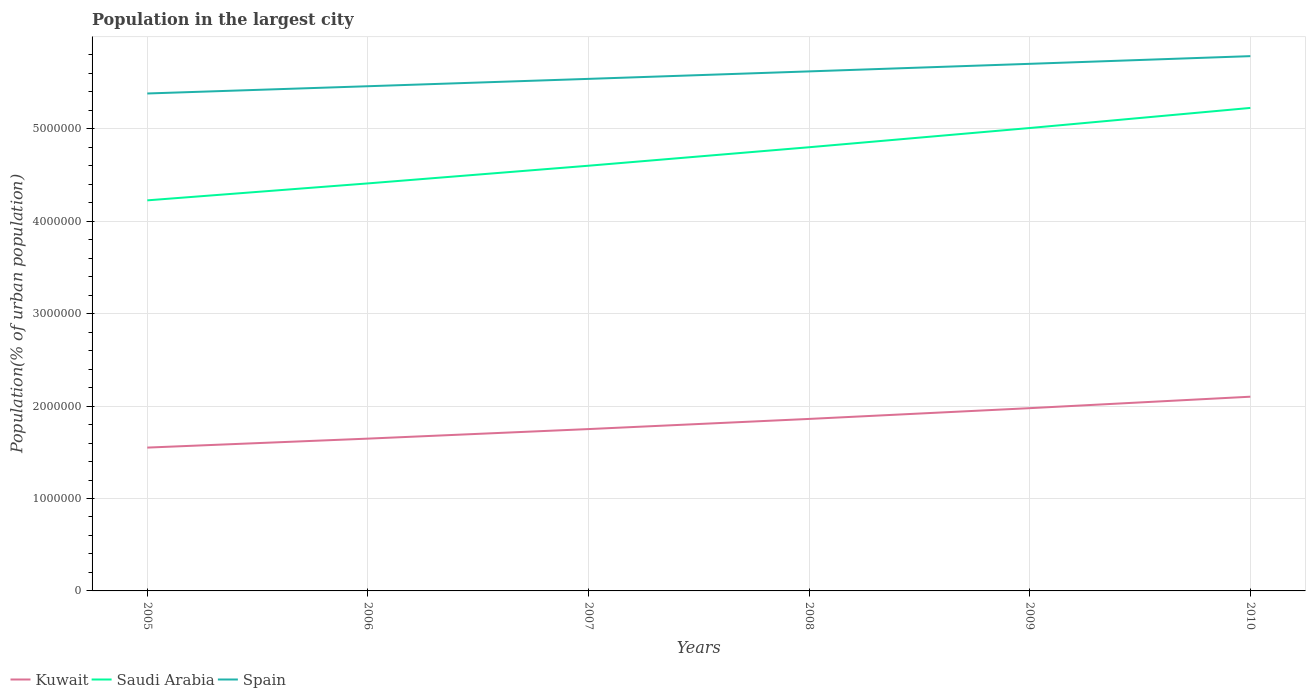Does the line corresponding to Kuwait intersect with the line corresponding to Saudi Arabia?
Provide a succinct answer. No. Is the number of lines equal to the number of legend labels?
Offer a very short reply. Yes. Across all years, what is the maximum population in the largest city in Spain?
Your answer should be very brief. 5.38e+06. In which year was the population in the largest city in Saudi Arabia maximum?
Provide a short and direct response. 2005. What is the total population in the largest city in Kuwait in the graph?
Provide a short and direct response. -2.26e+05. What is the difference between the highest and the second highest population in the largest city in Spain?
Provide a short and direct response. 4.04e+05. Is the population in the largest city in Saudi Arabia strictly greater than the population in the largest city in Kuwait over the years?
Keep it short and to the point. No. How many lines are there?
Your answer should be compact. 3. How many years are there in the graph?
Offer a terse response. 6. Does the graph contain grids?
Give a very brief answer. Yes. Where does the legend appear in the graph?
Provide a short and direct response. Bottom left. How are the legend labels stacked?
Offer a terse response. Horizontal. What is the title of the graph?
Provide a succinct answer. Population in the largest city. What is the label or title of the X-axis?
Your response must be concise. Years. What is the label or title of the Y-axis?
Make the answer very short. Population(% of urban population). What is the Population(% of urban population) of Kuwait in 2005?
Your response must be concise. 1.55e+06. What is the Population(% of urban population) of Saudi Arabia in 2005?
Ensure brevity in your answer.  4.23e+06. What is the Population(% of urban population) of Spain in 2005?
Give a very brief answer. 5.38e+06. What is the Population(% of urban population) of Kuwait in 2006?
Provide a short and direct response. 1.65e+06. What is the Population(% of urban population) of Saudi Arabia in 2006?
Offer a terse response. 4.41e+06. What is the Population(% of urban population) of Spain in 2006?
Offer a terse response. 5.46e+06. What is the Population(% of urban population) of Kuwait in 2007?
Provide a short and direct response. 1.75e+06. What is the Population(% of urban population) of Saudi Arabia in 2007?
Offer a terse response. 4.60e+06. What is the Population(% of urban population) of Spain in 2007?
Keep it short and to the point. 5.54e+06. What is the Population(% of urban population) in Kuwait in 2008?
Your response must be concise. 1.86e+06. What is the Population(% of urban population) in Saudi Arabia in 2008?
Make the answer very short. 4.80e+06. What is the Population(% of urban population) in Spain in 2008?
Your answer should be very brief. 5.62e+06. What is the Population(% of urban population) of Kuwait in 2009?
Offer a terse response. 1.98e+06. What is the Population(% of urban population) in Saudi Arabia in 2009?
Provide a short and direct response. 5.01e+06. What is the Population(% of urban population) in Spain in 2009?
Make the answer very short. 5.70e+06. What is the Population(% of urban population) of Kuwait in 2010?
Provide a succinct answer. 2.10e+06. What is the Population(% of urban population) of Saudi Arabia in 2010?
Offer a terse response. 5.23e+06. What is the Population(% of urban population) of Spain in 2010?
Provide a succinct answer. 5.79e+06. Across all years, what is the maximum Population(% of urban population) in Kuwait?
Ensure brevity in your answer.  2.10e+06. Across all years, what is the maximum Population(% of urban population) in Saudi Arabia?
Your answer should be compact. 5.23e+06. Across all years, what is the maximum Population(% of urban population) of Spain?
Your response must be concise. 5.79e+06. Across all years, what is the minimum Population(% of urban population) of Kuwait?
Provide a succinct answer. 1.55e+06. Across all years, what is the minimum Population(% of urban population) of Saudi Arabia?
Provide a succinct answer. 4.23e+06. Across all years, what is the minimum Population(% of urban population) in Spain?
Keep it short and to the point. 5.38e+06. What is the total Population(% of urban population) in Kuwait in the graph?
Give a very brief answer. 1.09e+07. What is the total Population(% of urban population) in Saudi Arabia in the graph?
Provide a succinct answer. 2.83e+07. What is the total Population(% of urban population) in Spain in the graph?
Provide a succinct answer. 3.35e+07. What is the difference between the Population(% of urban population) of Kuwait in 2005 and that in 2006?
Your response must be concise. -9.72e+04. What is the difference between the Population(% of urban population) in Saudi Arabia in 2005 and that in 2006?
Offer a very short reply. -1.83e+05. What is the difference between the Population(% of urban population) of Spain in 2005 and that in 2006?
Ensure brevity in your answer.  -7.85e+04. What is the difference between the Population(% of urban population) in Kuwait in 2005 and that in 2007?
Your answer should be very brief. -2.00e+05. What is the difference between the Population(% of urban population) in Saudi Arabia in 2005 and that in 2007?
Your answer should be very brief. -3.75e+05. What is the difference between the Population(% of urban population) of Spain in 2005 and that in 2007?
Provide a succinct answer. -1.58e+05. What is the difference between the Population(% of urban population) of Kuwait in 2005 and that in 2008?
Offer a terse response. -3.10e+05. What is the difference between the Population(% of urban population) in Saudi Arabia in 2005 and that in 2008?
Offer a very short reply. -5.75e+05. What is the difference between the Population(% of urban population) in Spain in 2005 and that in 2008?
Your answer should be compact. -2.39e+05. What is the difference between the Population(% of urban population) of Kuwait in 2005 and that in 2009?
Offer a terse response. -4.27e+05. What is the difference between the Population(% of urban population) of Saudi Arabia in 2005 and that in 2009?
Your answer should be compact. -7.83e+05. What is the difference between the Population(% of urban population) in Spain in 2005 and that in 2009?
Give a very brief answer. -3.21e+05. What is the difference between the Population(% of urban population) of Kuwait in 2005 and that in 2010?
Ensure brevity in your answer.  -5.51e+05. What is the difference between the Population(% of urban population) of Saudi Arabia in 2005 and that in 2010?
Your answer should be very brief. -1.00e+06. What is the difference between the Population(% of urban population) of Spain in 2005 and that in 2010?
Give a very brief answer. -4.04e+05. What is the difference between the Population(% of urban population) in Kuwait in 2006 and that in 2007?
Your response must be concise. -1.03e+05. What is the difference between the Population(% of urban population) in Saudi Arabia in 2006 and that in 2007?
Provide a succinct answer. -1.91e+05. What is the difference between the Population(% of urban population) of Spain in 2006 and that in 2007?
Give a very brief answer. -7.96e+04. What is the difference between the Population(% of urban population) in Kuwait in 2006 and that in 2008?
Offer a very short reply. -2.13e+05. What is the difference between the Population(% of urban population) in Saudi Arabia in 2006 and that in 2008?
Keep it short and to the point. -3.91e+05. What is the difference between the Population(% of urban population) of Spain in 2006 and that in 2008?
Offer a terse response. -1.61e+05. What is the difference between the Population(% of urban population) of Kuwait in 2006 and that in 2009?
Make the answer very short. -3.30e+05. What is the difference between the Population(% of urban population) in Saudi Arabia in 2006 and that in 2009?
Offer a terse response. -5.99e+05. What is the difference between the Population(% of urban population) of Spain in 2006 and that in 2009?
Provide a short and direct response. -2.42e+05. What is the difference between the Population(% of urban population) in Kuwait in 2006 and that in 2010?
Make the answer very short. -4.54e+05. What is the difference between the Population(% of urban population) in Saudi Arabia in 2006 and that in 2010?
Your answer should be very brief. -8.17e+05. What is the difference between the Population(% of urban population) in Spain in 2006 and that in 2010?
Your answer should be compact. -3.26e+05. What is the difference between the Population(% of urban population) of Kuwait in 2007 and that in 2008?
Ensure brevity in your answer.  -1.10e+05. What is the difference between the Population(% of urban population) in Saudi Arabia in 2007 and that in 2008?
Offer a terse response. -2.00e+05. What is the difference between the Population(% of urban population) in Spain in 2007 and that in 2008?
Make the answer very short. -8.09e+04. What is the difference between the Population(% of urban population) of Kuwait in 2007 and that in 2009?
Make the answer very short. -2.26e+05. What is the difference between the Population(% of urban population) of Saudi Arabia in 2007 and that in 2009?
Offer a terse response. -4.08e+05. What is the difference between the Population(% of urban population) of Spain in 2007 and that in 2009?
Offer a very short reply. -1.63e+05. What is the difference between the Population(% of urban population) in Kuwait in 2007 and that in 2010?
Provide a succinct answer. -3.50e+05. What is the difference between the Population(% of urban population) in Saudi Arabia in 2007 and that in 2010?
Your answer should be very brief. -6.25e+05. What is the difference between the Population(% of urban population) of Spain in 2007 and that in 2010?
Keep it short and to the point. -2.46e+05. What is the difference between the Population(% of urban population) in Kuwait in 2008 and that in 2009?
Offer a terse response. -1.16e+05. What is the difference between the Population(% of urban population) of Saudi Arabia in 2008 and that in 2009?
Your response must be concise. -2.08e+05. What is the difference between the Population(% of urban population) in Spain in 2008 and that in 2009?
Offer a terse response. -8.18e+04. What is the difference between the Population(% of urban population) in Kuwait in 2008 and that in 2010?
Offer a terse response. -2.40e+05. What is the difference between the Population(% of urban population) in Saudi Arabia in 2008 and that in 2010?
Your response must be concise. -4.25e+05. What is the difference between the Population(% of urban population) of Spain in 2008 and that in 2010?
Keep it short and to the point. -1.65e+05. What is the difference between the Population(% of urban population) of Kuwait in 2009 and that in 2010?
Make the answer very short. -1.24e+05. What is the difference between the Population(% of urban population) in Saudi Arabia in 2009 and that in 2010?
Offer a terse response. -2.17e+05. What is the difference between the Population(% of urban population) of Spain in 2009 and that in 2010?
Provide a short and direct response. -8.32e+04. What is the difference between the Population(% of urban population) of Kuwait in 2005 and the Population(% of urban population) of Saudi Arabia in 2006?
Offer a very short reply. -2.86e+06. What is the difference between the Population(% of urban population) of Kuwait in 2005 and the Population(% of urban population) of Spain in 2006?
Provide a short and direct response. -3.91e+06. What is the difference between the Population(% of urban population) in Saudi Arabia in 2005 and the Population(% of urban population) in Spain in 2006?
Ensure brevity in your answer.  -1.24e+06. What is the difference between the Population(% of urban population) in Kuwait in 2005 and the Population(% of urban population) in Saudi Arabia in 2007?
Offer a terse response. -3.05e+06. What is the difference between the Population(% of urban population) of Kuwait in 2005 and the Population(% of urban population) of Spain in 2007?
Your response must be concise. -3.99e+06. What is the difference between the Population(% of urban population) in Saudi Arabia in 2005 and the Population(% of urban population) in Spain in 2007?
Give a very brief answer. -1.31e+06. What is the difference between the Population(% of urban population) in Kuwait in 2005 and the Population(% of urban population) in Saudi Arabia in 2008?
Offer a very short reply. -3.25e+06. What is the difference between the Population(% of urban population) in Kuwait in 2005 and the Population(% of urban population) in Spain in 2008?
Give a very brief answer. -4.07e+06. What is the difference between the Population(% of urban population) of Saudi Arabia in 2005 and the Population(% of urban population) of Spain in 2008?
Give a very brief answer. -1.40e+06. What is the difference between the Population(% of urban population) in Kuwait in 2005 and the Population(% of urban population) in Saudi Arabia in 2009?
Your answer should be compact. -3.46e+06. What is the difference between the Population(% of urban population) of Kuwait in 2005 and the Population(% of urban population) of Spain in 2009?
Provide a succinct answer. -4.15e+06. What is the difference between the Population(% of urban population) in Saudi Arabia in 2005 and the Population(% of urban population) in Spain in 2009?
Give a very brief answer. -1.48e+06. What is the difference between the Population(% of urban population) of Kuwait in 2005 and the Population(% of urban population) of Saudi Arabia in 2010?
Provide a succinct answer. -3.68e+06. What is the difference between the Population(% of urban population) in Kuwait in 2005 and the Population(% of urban population) in Spain in 2010?
Ensure brevity in your answer.  -4.24e+06. What is the difference between the Population(% of urban population) in Saudi Arabia in 2005 and the Population(% of urban population) in Spain in 2010?
Give a very brief answer. -1.56e+06. What is the difference between the Population(% of urban population) in Kuwait in 2006 and the Population(% of urban population) in Saudi Arabia in 2007?
Your answer should be very brief. -2.95e+06. What is the difference between the Population(% of urban population) of Kuwait in 2006 and the Population(% of urban population) of Spain in 2007?
Your answer should be compact. -3.89e+06. What is the difference between the Population(% of urban population) of Saudi Arabia in 2006 and the Population(% of urban population) of Spain in 2007?
Ensure brevity in your answer.  -1.13e+06. What is the difference between the Population(% of urban population) of Kuwait in 2006 and the Population(% of urban population) of Saudi Arabia in 2008?
Your answer should be compact. -3.15e+06. What is the difference between the Population(% of urban population) of Kuwait in 2006 and the Population(% of urban population) of Spain in 2008?
Your answer should be very brief. -3.97e+06. What is the difference between the Population(% of urban population) in Saudi Arabia in 2006 and the Population(% of urban population) in Spain in 2008?
Make the answer very short. -1.21e+06. What is the difference between the Population(% of urban population) in Kuwait in 2006 and the Population(% of urban population) in Saudi Arabia in 2009?
Offer a very short reply. -3.36e+06. What is the difference between the Population(% of urban population) of Kuwait in 2006 and the Population(% of urban population) of Spain in 2009?
Keep it short and to the point. -4.06e+06. What is the difference between the Population(% of urban population) in Saudi Arabia in 2006 and the Population(% of urban population) in Spain in 2009?
Offer a very short reply. -1.29e+06. What is the difference between the Population(% of urban population) of Kuwait in 2006 and the Population(% of urban population) of Saudi Arabia in 2010?
Your answer should be compact. -3.58e+06. What is the difference between the Population(% of urban population) of Kuwait in 2006 and the Population(% of urban population) of Spain in 2010?
Keep it short and to the point. -4.14e+06. What is the difference between the Population(% of urban population) in Saudi Arabia in 2006 and the Population(% of urban population) in Spain in 2010?
Provide a short and direct response. -1.38e+06. What is the difference between the Population(% of urban population) in Kuwait in 2007 and the Population(% of urban population) in Saudi Arabia in 2008?
Offer a terse response. -3.05e+06. What is the difference between the Population(% of urban population) of Kuwait in 2007 and the Population(% of urban population) of Spain in 2008?
Provide a succinct answer. -3.87e+06. What is the difference between the Population(% of urban population) in Saudi Arabia in 2007 and the Population(% of urban population) in Spain in 2008?
Make the answer very short. -1.02e+06. What is the difference between the Population(% of urban population) in Kuwait in 2007 and the Population(% of urban population) in Saudi Arabia in 2009?
Provide a succinct answer. -3.26e+06. What is the difference between the Population(% of urban population) of Kuwait in 2007 and the Population(% of urban population) of Spain in 2009?
Your response must be concise. -3.95e+06. What is the difference between the Population(% of urban population) of Saudi Arabia in 2007 and the Population(% of urban population) of Spain in 2009?
Keep it short and to the point. -1.10e+06. What is the difference between the Population(% of urban population) in Kuwait in 2007 and the Population(% of urban population) in Saudi Arabia in 2010?
Offer a terse response. -3.48e+06. What is the difference between the Population(% of urban population) of Kuwait in 2007 and the Population(% of urban population) of Spain in 2010?
Your response must be concise. -4.04e+06. What is the difference between the Population(% of urban population) in Saudi Arabia in 2007 and the Population(% of urban population) in Spain in 2010?
Provide a short and direct response. -1.19e+06. What is the difference between the Population(% of urban population) of Kuwait in 2008 and the Population(% of urban population) of Saudi Arabia in 2009?
Offer a terse response. -3.15e+06. What is the difference between the Population(% of urban population) in Kuwait in 2008 and the Population(% of urban population) in Spain in 2009?
Keep it short and to the point. -3.84e+06. What is the difference between the Population(% of urban population) of Saudi Arabia in 2008 and the Population(% of urban population) of Spain in 2009?
Your answer should be very brief. -9.03e+05. What is the difference between the Population(% of urban population) of Kuwait in 2008 and the Population(% of urban population) of Saudi Arabia in 2010?
Your answer should be very brief. -3.37e+06. What is the difference between the Population(% of urban population) in Kuwait in 2008 and the Population(% of urban population) in Spain in 2010?
Provide a succinct answer. -3.93e+06. What is the difference between the Population(% of urban population) of Saudi Arabia in 2008 and the Population(% of urban population) of Spain in 2010?
Give a very brief answer. -9.86e+05. What is the difference between the Population(% of urban population) of Kuwait in 2009 and the Population(% of urban population) of Saudi Arabia in 2010?
Ensure brevity in your answer.  -3.25e+06. What is the difference between the Population(% of urban population) of Kuwait in 2009 and the Population(% of urban population) of Spain in 2010?
Keep it short and to the point. -3.81e+06. What is the difference between the Population(% of urban population) in Saudi Arabia in 2009 and the Population(% of urban population) in Spain in 2010?
Your answer should be very brief. -7.78e+05. What is the average Population(% of urban population) of Kuwait per year?
Provide a short and direct response. 1.82e+06. What is the average Population(% of urban population) in Saudi Arabia per year?
Keep it short and to the point. 4.71e+06. What is the average Population(% of urban population) in Spain per year?
Keep it short and to the point. 5.58e+06. In the year 2005, what is the difference between the Population(% of urban population) of Kuwait and Population(% of urban population) of Saudi Arabia?
Provide a succinct answer. -2.68e+06. In the year 2005, what is the difference between the Population(% of urban population) in Kuwait and Population(% of urban population) in Spain?
Give a very brief answer. -3.83e+06. In the year 2005, what is the difference between the Population(% of urban population) of Saudi Arabia and Population(% of urban population) of Spain?
Provide a succinct answer. -1.16e+06. In the year 2006, what is the difference between the Population(% of urban population) of Kuwait and Population(% of urban population) of Saudi Arabia?
Keep it short and to the point. -2.76e+06. In the year 2006, what is the difference between the Population(% of urban population) of Kuwait and Population(% of urban population) of Spain?
Offer a terse response. -3.81e+06. In the year 2006, what is the difference between the Population(% of urban population) of Saudi Arabia and Population(% of urban population) of Spain?
Your answer should be compact. -1.05e+06. In the year 2007, what is the difference between the Population(% of urban population) in Kuwait and Population(% of urban population) in Saudi Arabia?
Make the answer very short. -2.85e+06. In the year 2007, what is the difference between the Population(% of urban population) in Kuwait and Population(% of urban population) in Spain?
Your answer should be very brief. -3.79e+06. In the year 2007, what is the difference between the Population(% of urban population) of Saudi Arabia and Population(% of urban population) of Spain?
Offer a terse response. -9.40e+05. In the year 2008, what is the difference between the Population(% of urban population) in Kuwait and Population(% of urban population) in Saudi Arabia?
Offer a very short reply. -2.94e+06. In the year 2008, what is the difference between the Population(% of urban population) in Kuwait and Population(% of urban population) in Spain?
Offer a very short reply. -3.76e+06. In the year 2008, what is the difference between the Population(% of urban population) of Saudi Arabia and Population(% of urban population) of Spain?
Offer a terse response. -8.21e+05. In the year 2009, what is the difference between the Population(% of urban population) in Kuwait and Population(% of urban population) in Saudi Arabia?
Your answer should be very brief. -3.03e+06. In the year 2009, what is the difference between the Population(% of urban population) in Kuwait and Population(% of urban population) in Spain?
Your answer should be compact. -3.73e+06. In the year 2009, what is the difference between the Population(% of urban population) of Saudi Arabia and Population(% of urban population) of Spain?
Your answer should be very brief. -6.95e+05. In the year 2010, what is the difference between the Population(% of urban population) of Kuwait and Population(% of urban population) of Saudi Arabia?
Offer a terse response. -3.13e+06. In the year 2010, what is the difference between the Population(% of urban population) of Kuwait and Population(% of urban population) of Spain?
Your answer should be compact. -3.69e+06. In the year 2010, what is the difference between the Population(% of urban population) in Saudi Arabia and Population(% of urban population) in Spain?
Provide a short and direct response. -5.60e+05. What is the ratio of the Population(% of urban population) of Kuwait in 2005 to that in 2006?
Offer a very short reply. 0.94. What is the ratio of the Population(% of urban population) in Saudi Arabia in 2005 to that in 2006?
Ensure brevity in your answer.  0.96. What is the ratio of the Population(% of urban population) in Spain in 2005 to that in 2006?
Give a very brief answer. 0.99. What is the ratio of the Population(% of urban population) in Kuwait in 2005 to that in 2007?
Keep it short and to the point. 0.89. What is the ratio of the Population(% of urban population) of Saudi Arabia in 2005 to that in 2007?
Offer a very short reply. 0.92. What is the ratio of the Population(% of urban population) in Spain in 2005 to that in 2007?
Offer a terse response. 0.97. What is the ratio of the Population(% of urban population) of Kuwait in 2005 to that in 2008?
Your answer should be compact. 0.83. What is the ratio of the Population(% of urban population) in Saudi Arabia in 2005 to that in 2008?
Make the answer very short. 0.88. What is the ratio of the Population(% of urban population) of Spain in 2005 to that in 2008?
Ensure brevity in your answer.  0.96. What is the ratio of the Population(% of urban population) in Kuwait in 2005 to that in 2009?
Your answer should be compact. 0.78. What is the ratio of the Population(% of urban population) in Saudi Arabia in 2005 to that in 2009?
Ensure brevity in your answer.  0.84. What is the ratio of the Population(% of urban population) of Spain in 2005 to that in 2009?
Keep it short and to the point. 0.94. What is the ratio of the Population(% of urban population) in Kuwait in 2005 to that in 2010?
Your answer should be very brief. 0.74. What is the ratio of the Population(% of urban population) in Saudi Arabia in 2005 to that in 2010?
Your answer should be compact. 0.81. What is the ratio of the Population(% of urban population) of Spain in 2005 to that in 2010?
Make the answer very short. 0.93. What is the ratio of the Population(% of urban population) in Kuwait in 2006 to that in 2007?
Provide a short and direct response. 0.94. What is the ratio of the Population(% of urban population) in Saudi Arabia in 2006 to that in 2007?
Give a very brief answer. 0.96. What is the ratio of the Population(% of urban population) in Spain in 2006 to that in 2007?
Your response must be concise. 0.99. What is the ratio of the Population(% of urban population) in Kuwait in 2006 to that in 2008?
Provide a succinct answer. 0.89. What is the ratio of the Population(% of urban population) in Saudi Arabia in 2006 to that in 2008?
Your answer should be very brief. 0.92. What is the ratio of the Population(% of urban population) of Spain in 2006 to that in 2008?
Your response must be concise. 0.97. What is the ratio of the Population(% of urban population) in Kuwait in 2006 to that in 2009?
Offer a terse response. 0.83. What is the ratio of the Population(% of urban population) in Saudi Arabia in 2006 to that in 2009?
Keep it short and to the point. 0.88. What is the ratio of the Population(% of urban population) of Spain in 2006 to that in 2009?
Your answer should be very brief. 0.96. What is the ratio of the Population(% of urban population) in Kuwait in 2006 to that in 2010?
Your response must be concise. 0.78. What is the ratio of the Population(% of urban population) in Saudi Arabia in 2006 to that in 2010?
Keep it short and to the point. 0.84. What is the ratio of the Population(% of urban population) in Spain in 2006 to that in 2010?
Your answer should be compact. 0.94. What is the ratio of the Population(% of urban population) in Kuwait in 2007 to that in 2008?
Your response must be concise. 0.94. What is the ratio of the Population(% of urban population) of Saudi Arabia in 2007 to that in 2008?
Your answer should be very brief. 0.96. What is the ratio of the Population(% of urban population) of Spain in 2007 to that in 2008?
Your response must be concise. 0.99. What is the ratio of the Population(% of urban population) of Kuwait in 2007 to that in 2009?
Offer a terse response. 0.89. What is the ratio of the Population(% of urban population) in Saudi Arabia in 2007 to that in 2009?
Keep it short and to the point. 0.92. What is the ratio of the Population(% of urban population) of Spain in 2007 to that in 2009?
Your answer should be compact. 0.97. What is the ratio of the Population(% of urban population) in Saudi Arabia in 2007 to that in 2010?
Ensure brevity in your answer.  0.88. What is the ratio of the Population(% of urban population) of Spain in 2007 to that in 2010?
Provide a succinct answer. 0.96. What is the ratio of the Population(% of urban population) in Kuwait in 2008 to that in 2009?
Provide a succinct answer. 0.94. What is the ratio of the Population(% of urban population) in Saudi Arabia in 2008 to that in 2009?
Offer a very short reply. 0.96. What is the ratio of the Population(% of urban population) of Spain in 2008 to that in 2009?
Ensure brevity in your answer.  0.99. What is the ratio of the Population(% of urban population) in Kuwait in 2008 to that in 2010?
Your response must be concise. 0.89. What is the ratio of the Population(% of urban population) of Saudi Arabia in 2008 to that in 2010?
Provide a succinct answer. 0.92. What is the ratio of the Population(% of urban population) of Spain in 2008 to that in 2010?
Ensure brevity in your answer.  0.97. What is the ratio of the Population(% of urban population) in Kuwait in 2009 to that in 2010?
Provide a short and direct response. 0.94. What is the ratio of the Population(% of urban population) in Saudi Arabia in 2009 to that in 2010?
Your answer should be very brief. 0.96. What is the ratio of the Population(% of urban population) of Spain in 2009 to that in 2010?
Offer a very short reply. 0.99. What is the difference between the highest and the second highest Population(% of urban population) in Kuwait?
Offer a terse response. 1.24e+05. What is the difference between the highest and the second highest Population(% of urban population) in Saudi Arabia?
Keep it short and to the point. 2.17e+05. What is the difference between the highest and the second highest Population(% of urban population) in Spain?
Your response must be concise. 8.32e+04. What is the difference between the highest and the lowest Population(% of urban population) of Kuwait?
Ensure brevity in your answer.  5.51e+05. What is the difference between the highest and the lowest Population(% of urban population) in Saudi Arabia?
Offer a very short reply. 1.00e+06. What is the difference between the highest and the lowest Population(% of urban population) in Spain?
Offer a terse response. 4.04e+05. 